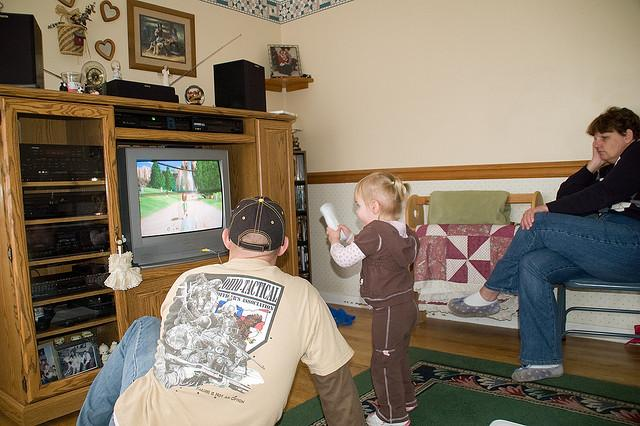What is the young girl doing with the white object? playing game 